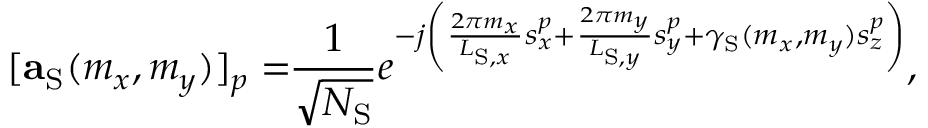<formula> <loc_0><loc_0><loc_500><loc_500>[ a _ { S } ( m _ { x } , m _ { y } ) ] _ { p } = \, \frac { 1 } { \sqrt { N _ { S } } } e ^ { - j \left ( \frac { 2 \pi m _ { x } } { L _ { S , x } } s _ { x } ^ { p } + \frac { 2 \pi m _ { y } } { L _ { S , y } } s _ { y } ^ { p } + \gamma _ { S } ( m _ { x } , m _ { y } ) s _ { z } ^ { p } \right ) } ,</formula> 